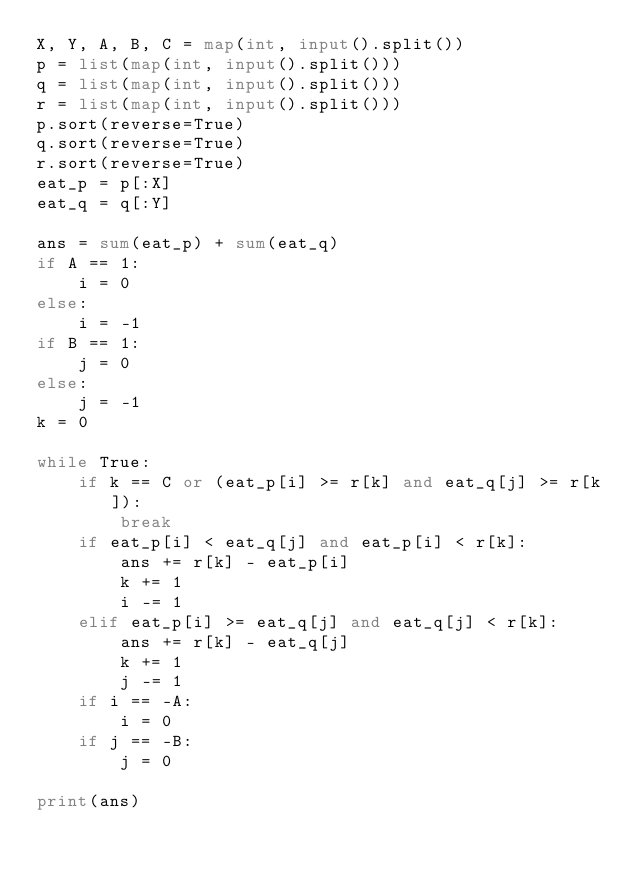<code> <loc_0><loc_0><loc_500><loc_500><_Python_>X, Y, A, B, C = map(int, input().split())
p = list(map(int, input().split()))
q = list(map(int, input().split()))
r = list(map(int, input().split()))
p.sort(reverse=True)
q.sort(reverse=True)
r.sort(reverse=True)
eat_p = p[:X]
eat_q = q[:Y]

ans = sum(eat_p) + sum(eat_q)
if A == 1:
    i = 0
else:
    i = -1
if B == 1:
    j = 0
else:
    j = -1
k = 0

while True:
    if k == C or (eat_p[i] >= r[k] and eat_q[j] >= r[k]):
        break
    if eat_p[i] < eat_q[j] and eat_p[i] < r[k]:
        ans += r[k] - eat_p[i]
        k += 1
        i -= 1
    elif eat_p[i] >= eat_q[j] and eat_q[j] < r[k]:
        ans += r[k] - eat_q[j]
        k += 1
        j -= 1
    if i == -A:
        i = 0
    if j == -B:
        j = 0

print(ans)
</code> 